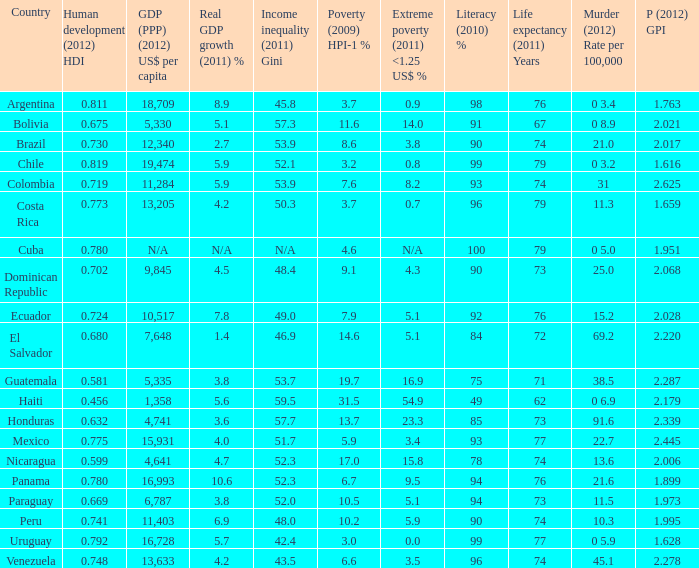What is the sum of poverty (2009) HPI-1 % when the GDP (PPP) (2012) US$ per capita of 11,284? 1.0. 